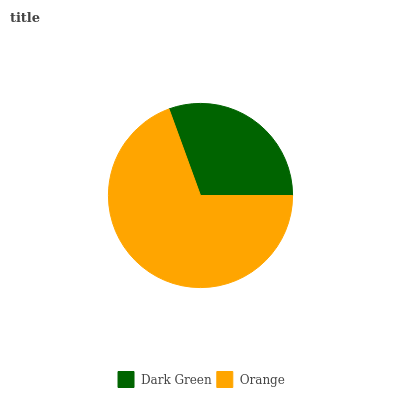Is Dark Green the minimum?
Answer yes or no. Yes. Is Orange the maximum?
Answer yes or no. Yes. Is Orange the minimum?
Answer yes or no. No. Is Orange greater than Dark Green?
Answer yes or no. Yes. Is Dark Green less than Orange?
Answer yes or no. Yes. Is Dark Green greater than Orange?
Answer yes or no. No. Is Orange less than Dark Green?
Answer yes or no. No. Is Orange the high median?
Answer yes or no. Yes. Is Dark Green the low median?
Answer yes or no. Yes. Is Dark Green the high median?
Answer yes or no. No. Is Orange the low median?
Answer yes or no. No. 